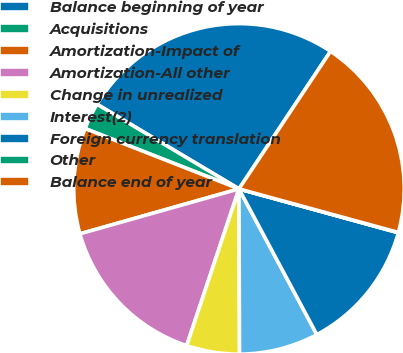<chart> <loc_0><loc_0><loc_500><loc_500><pie_chart><fcel>Balance beginning of year<fcel>Acquisitions<fcel>Amortization-Impact of<fcel>Amortization-All other<fcel>Change in unrealized<fcel>Interest(2)<fcel>Foreign currency translation<fcel>Other<fcel>Balance end of year<nl><fcel>25.79%<fcel>2.61%<fcel>10.33%<fcel>15.49%<fcel>5.18%<fcel>7.76%<fcel>12.91%<fcel>0.03%<fcel>19.9%<nl></chart> 